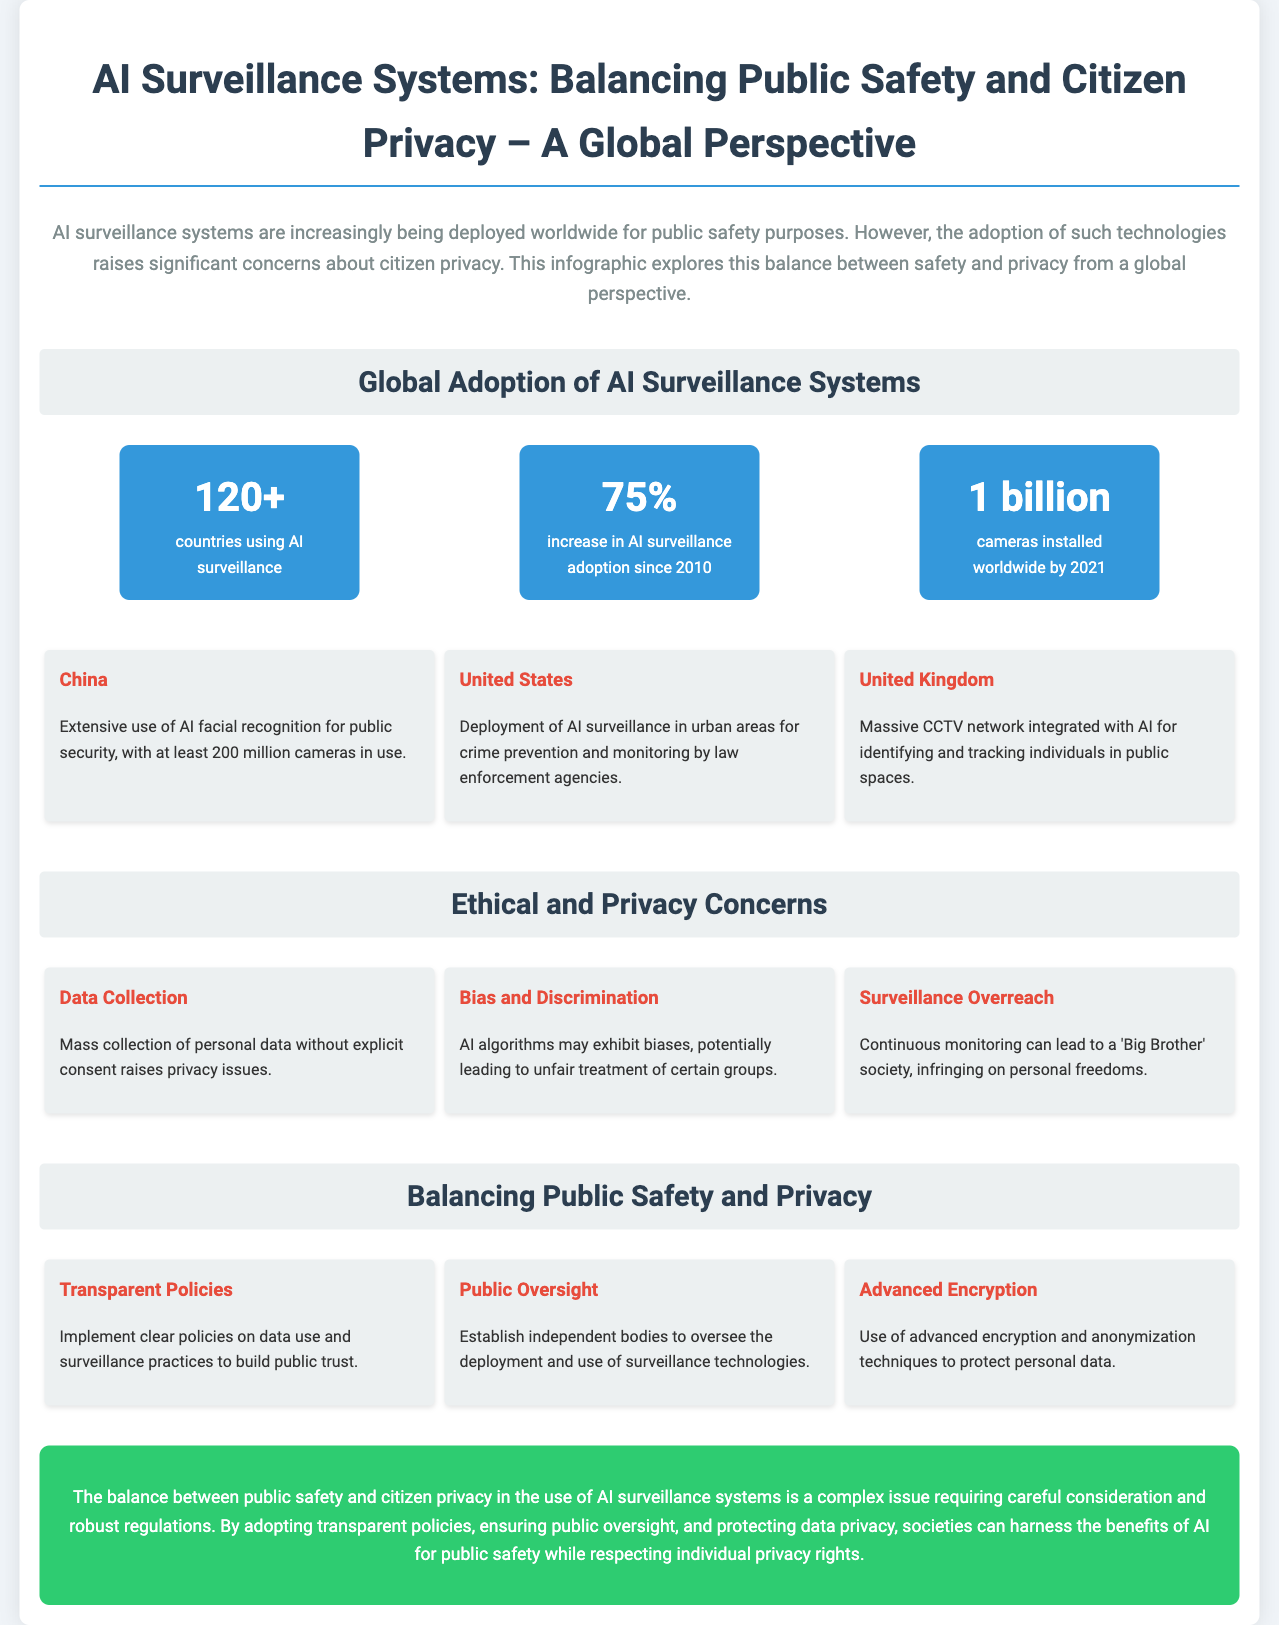What is the number of countries using AI surveillance? The document states that there are over 120 countries using AI surveillance systems.
Answer: 120+ What percentage increase in AI surveillance adoption has occurred since 2010? The infographic mentions a 75% increase in adoption since 2010.
Answer: 75% What is cited as a major ethical concern regarding AI surveillance? The document highlights concerns over mass collection of personal data without explicit consent.
Answer: Data Collection Which country is noted for having at least 200 million cameras in use? The example provided mentions that China has extensive use of AI facial recognition with at least 200 million cameras.
Answer: China What strategy is suggested for balancing public safety and privacy? The document suggests adopting transparent policies on data use and surveillance practices.
Answer: Transparent Policies What is the total number of cameras installed worldwide by 2021? According to the document, there were approximately 1 billion cameras installed worldwide by 2021.
Answer: 1 billion What is one potential negative outcome of surveillance mentioned in the document? The infographic discusses the potential for continuous monitoring to lead to a 'Big Brother' society.
Answer: Surveillance Overreach Which country shows deployment of AI surveillance in urban areas for crime prevention? The United States is noted for deploying AI surveillance in urban areas for crime prevention.
Answer: United States 